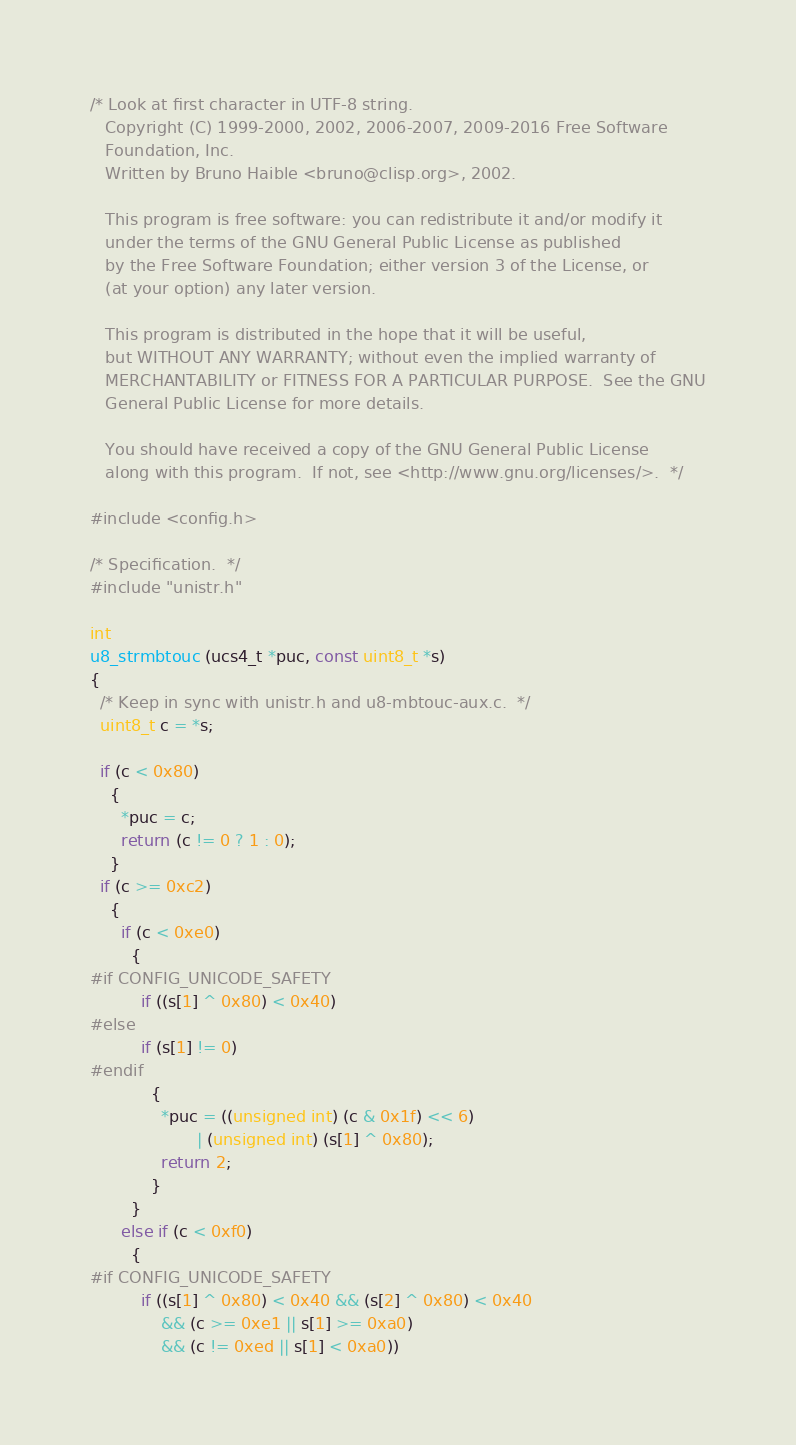<code> <loc_0><loc_0><loc_500><loc_500><_C_>/* Look at first character in UTF-8 string.
   Copyright (C) 1999-2000, 2002, 2006-2007, 2009-2016 Free Software
   Foundation, Inc.
   Written by Bruno Haible <bruno@clisp.org>, 2002.

   This program is free software: you can redistribute it and/or modify it
   under the terms of the GNU General Public License as published
   by the Free Software Foundation; either version 3 of the License, or
   (at your option) any later version.

   This program is distributed in the hope that it will be useful,
   but WITHOUT ANY WARRANTY; without even the implied warranty of
   MERCHANTABILITY or FITNESS FOR A PARTICULAR PURPOSE.  See the GNU
   General Public License for more details.

   You should have received a copy of the GNU General Public License
   along with this program.  If not, see <http://www.gnu.org/licenses/>.  */

#include <config.h>

/* Specification.  */
#include "unistr.h"

int
u8_strmbtouc (ucs4_t *puc, const uint8_t *s)
{
  /* Keep in sync with unistr.h and u8-mbtouc-aux.c.  */
  uint8_t c = *s;

  if (c < 0x80)
    {
      *puc = c;
      return (c != 0 ? 1 : 0);
    }
  if (c >= 0xc2)
    {
      if (c < 0xe0)
        {
#if CONFIG_UNICODE_SAFETY
          if ((s[1] ^ 0x80) < 0x40)
#else
          if (s[1] != 0)
#endif
            {
              *puc = ((unsigned int) (c & 0x1f) << 6)
                     | (unsigned int) (s[1] ^ 0x80);
              return 2;
            }
        }
      else if (c < 0xf0)
        {
#if CONFIG_UNICODE_SAFETY
          if ((s[1] ^ 0x80) < 0x40 && (s[2] ^ 0x80) < 0x40
              && (c >= 0xe1 || s[1] >= 0xa0)
              && (c != 0xed || s[1] < 0xa0))</code> 